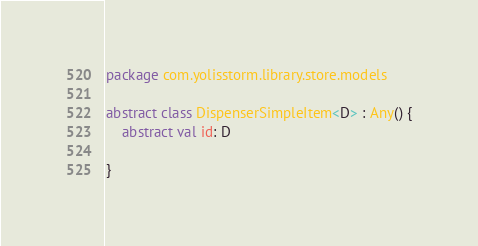<code> <loc_0><loc_0><loc_500><loc_500><_Kotlin_>package com.yolisstorm.library.store.models

abstract class DispenserSimpleItem<D> : Any() {
	abstract val id: D

}</code> 